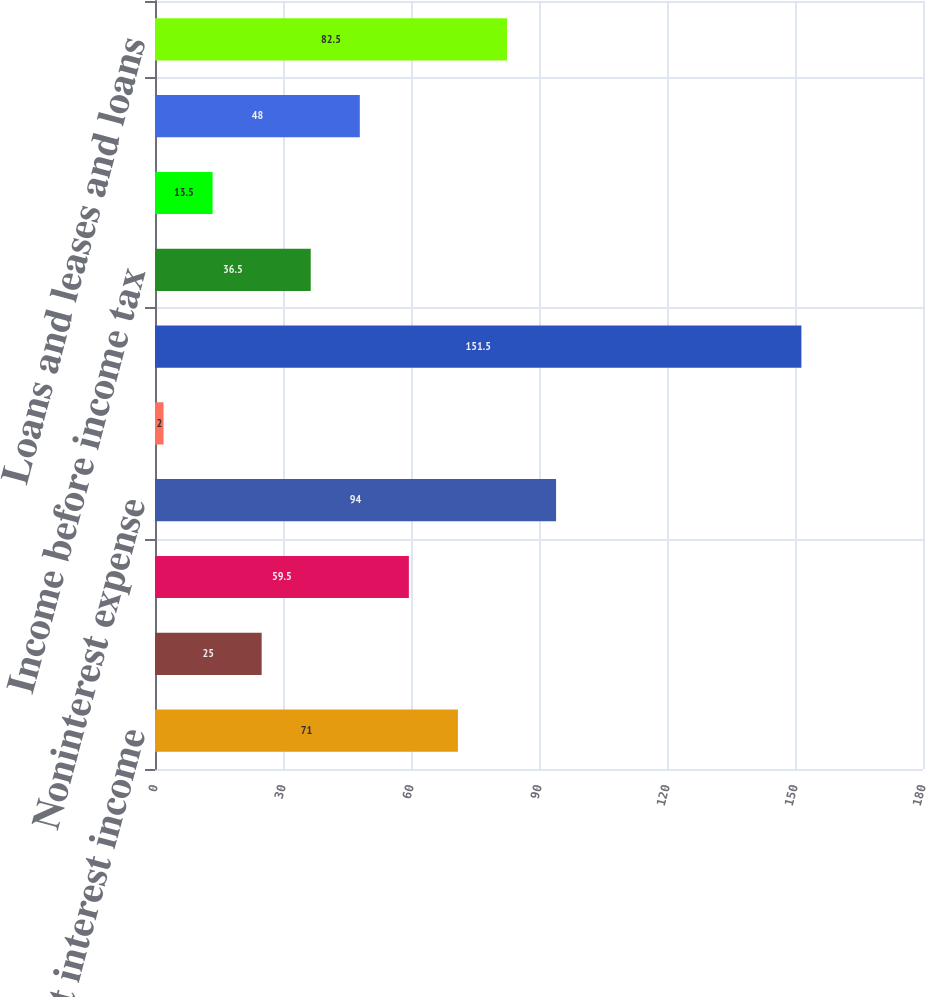<chart> <loc_0><loc_0><loc_500><loc_500><bar_chart><fcel>Net interest income<fcel>Noninterest income<fcel>Total revenue<fcel>Noninterest expense<fcel>Profit before provision for<fcel>Provision for credit losses<fcel>Income before income tax<fcel>Income tax expense<fcel>Net income<fcel>Loans and leases and loans<nl><fcel>71<fcel>25<fcel>59.5<fcel>94<fcel>2<fcel>151.5<fcel>36.5<fcel>13.5<fcel>48<fcel>82.5<nl></chart> 